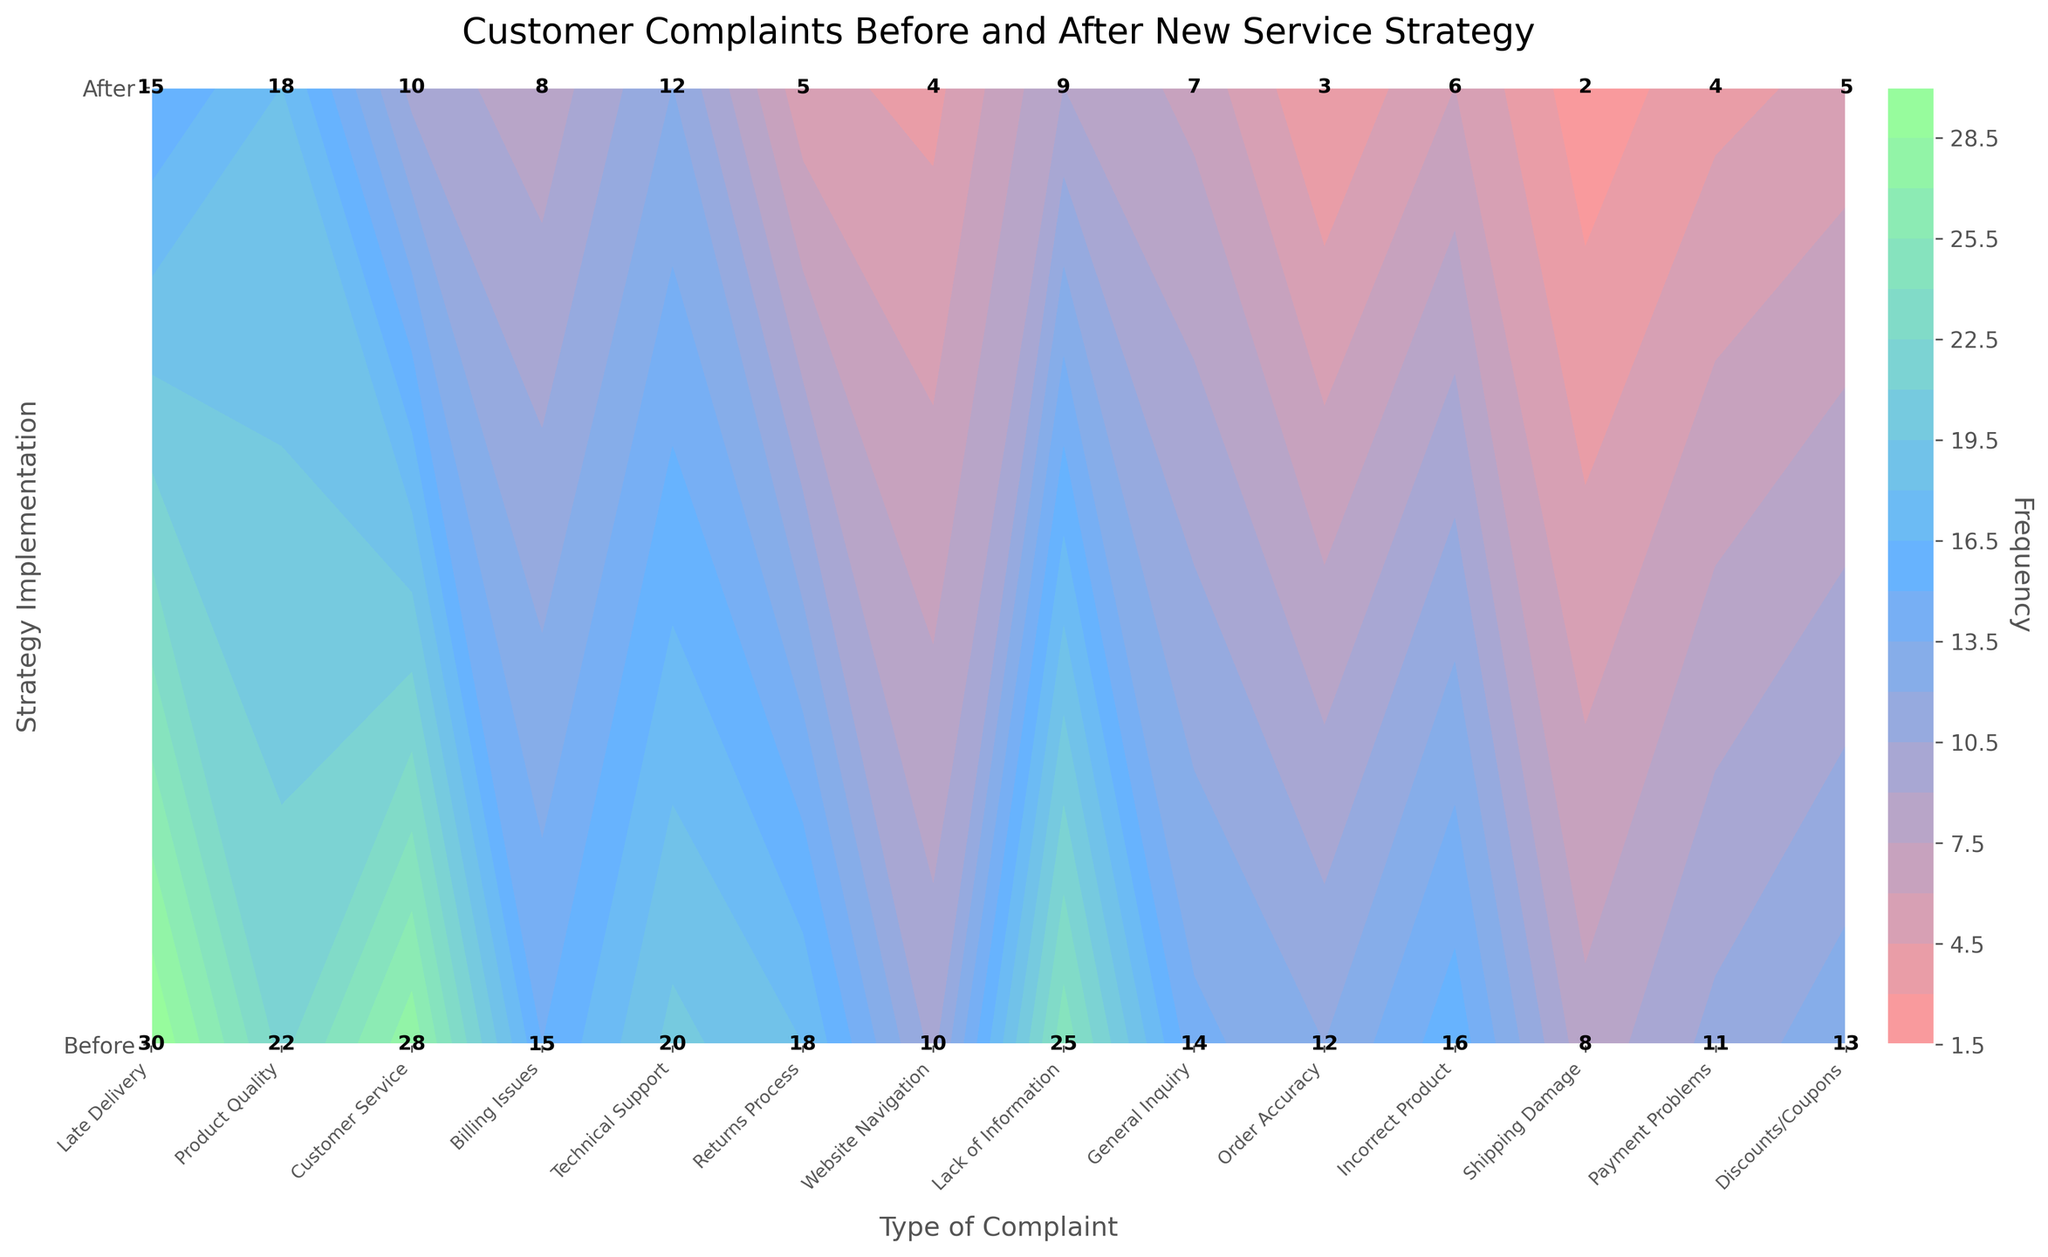What is the title of the plot? The title of the plot is shown at the top and is clearly labeled.
Answer: Customer Complaints Before and After New Service Strategy What are the two stages compared in the plot? The y-axis labels indicate the two stages being compared.
Answer: Before and After Which type of complaint had the highest frequency before implementing the new strategy? By looking at the labels on the x-axis and the contour plot, "Late Delivery" has the highest frequency before the new strategy, labeled as 30.
Answer: Late Delivery Which type of complaint saw the biggest reduction in frequency after the new strategy was implemented? Calculate the differences between frequency before and after for each complaint type. "Customer Service" has the largest difference (28 - 10 = 18).
Answer: Customer Service Identify a type of complaint that remained relatively consistent before and after the strategy implementation. By visually comparing the labels, "Product Quality" saw a slight reduction from 22 to 18, indicating relative consistency.
Answer: Product Quality What was the combined frequency of "Billing Issues" and "Technical Support" complaints before the strategy change? Add the frequencies before the strategy for both complaints: 15 (Billing Issues) + 20 (Technical Support).
Answer: 35 Which type of complaint had the lowest frequency after the strategy implementation? By evaluating the labels after the strategy, "Shipping Damage" had the lowest frequency with a value of 2.
Answer: Shipping Damage How many complaint types had their frequency reduced by more than 10 after implementing the new strategy? Calculate the differences for each type and count those greater than 10. They are: "Late Delivery" (15), "Customer Service" (18), "Lack of Information" (16), "Returns Process" (13).
Answer: 4 What is the color trend representing higher frequencies on the plot? The color trend can be observed in the contour, with darker shades representing higher frequencies. The darkest shade indicates higher frequencies.
Answer: Darker shades 